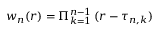<formula> <loc_0><loc_0><loc_500><loc_500>w _ { n } ( r ) = \Pi _ { k = 1 } ^ { n - 1 } \, ( r - \tau _ { n , k } )</formula> 